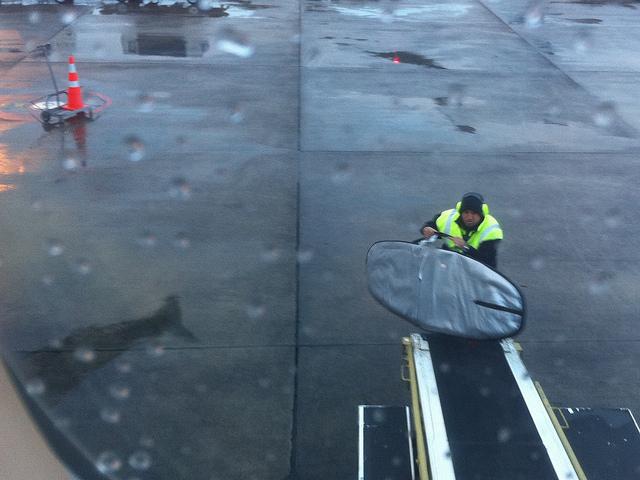Where is the man working?
Write a very short answer. Airport. Has it been raining in this picture?
Concise answer only. Yes. Is the man doing a rescuer?
Quick response, please. No. 